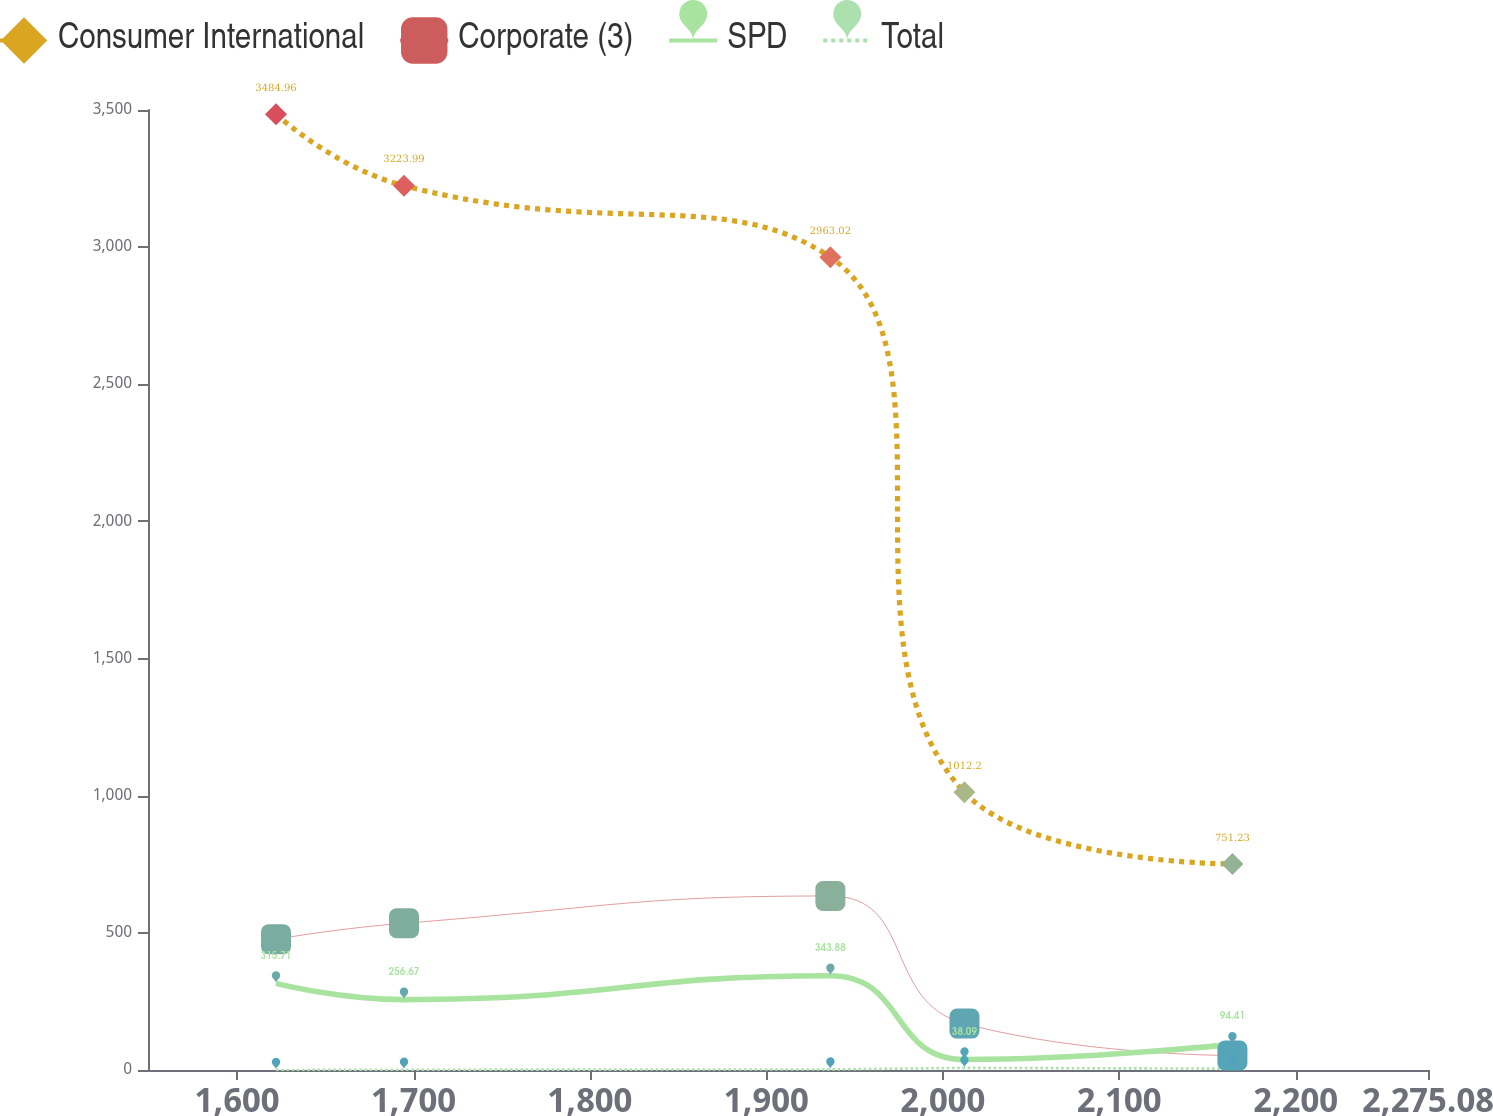Convert chart to OTSL. <chart><loc_0><loc_0><loc_500><loc_500><line_chart><ecel><fcel>Consumer International<fcel>Corporate (3)<fcel>SPD<fcel>Total<nl><fcel>1622.04<fcel>3484.96<fcel>476.9<fcel>315.71<fcel>0<nl><fcel>1694.6<fcel>3223.99<fcel>535.07<fcel>256.67<fcel>1<nl><fcel>1936.31<fcel>2963.02<fcel>634.5<fcel>343.88<fcel>2<nl><fcel>2012.31<fcel>1012.2<fcel>169.16<fcel>38.09<fcel>7.74<nl><fcel>2164.21<fcel>751.23<fcel>52.82<fcel>94.41<fcel>4.84<nl><fcel>2347.64<fcel>490.26<fcel>110.99<fcel>66.25<fcel>10.04<nl></chart> 